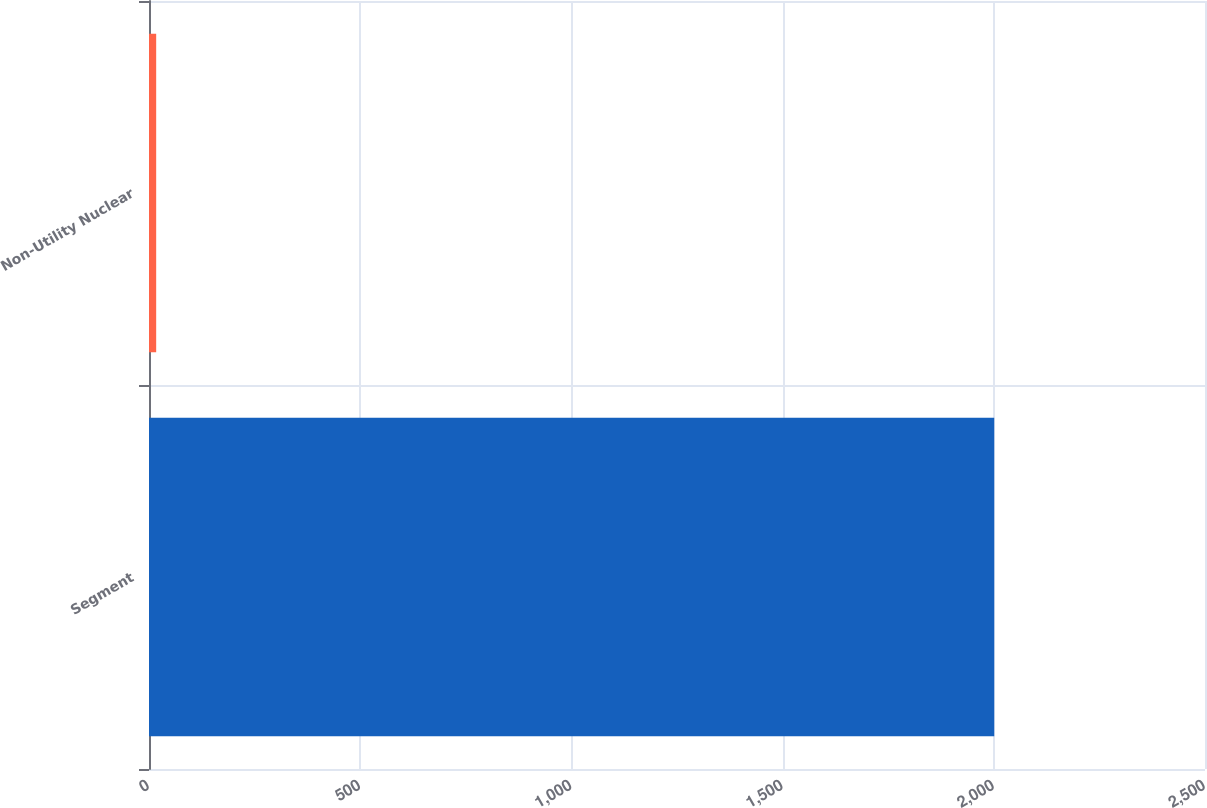Convert chart to OTSL. <chart><loc_0><loc_0><loc_500><loc_500><bar_chart><fcel>Segment<fcel>Non-Utility Nuclear<nl><fcel>2001<fcel>17<nl></chart> 